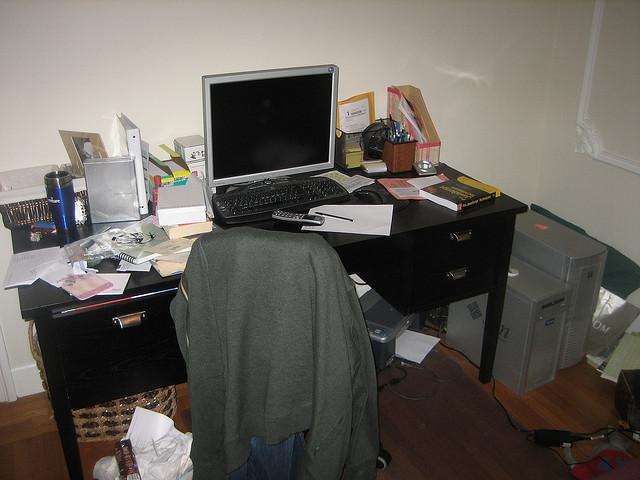What is in the room? Please explain your reasoning. messy desk. There is stuff all over it 